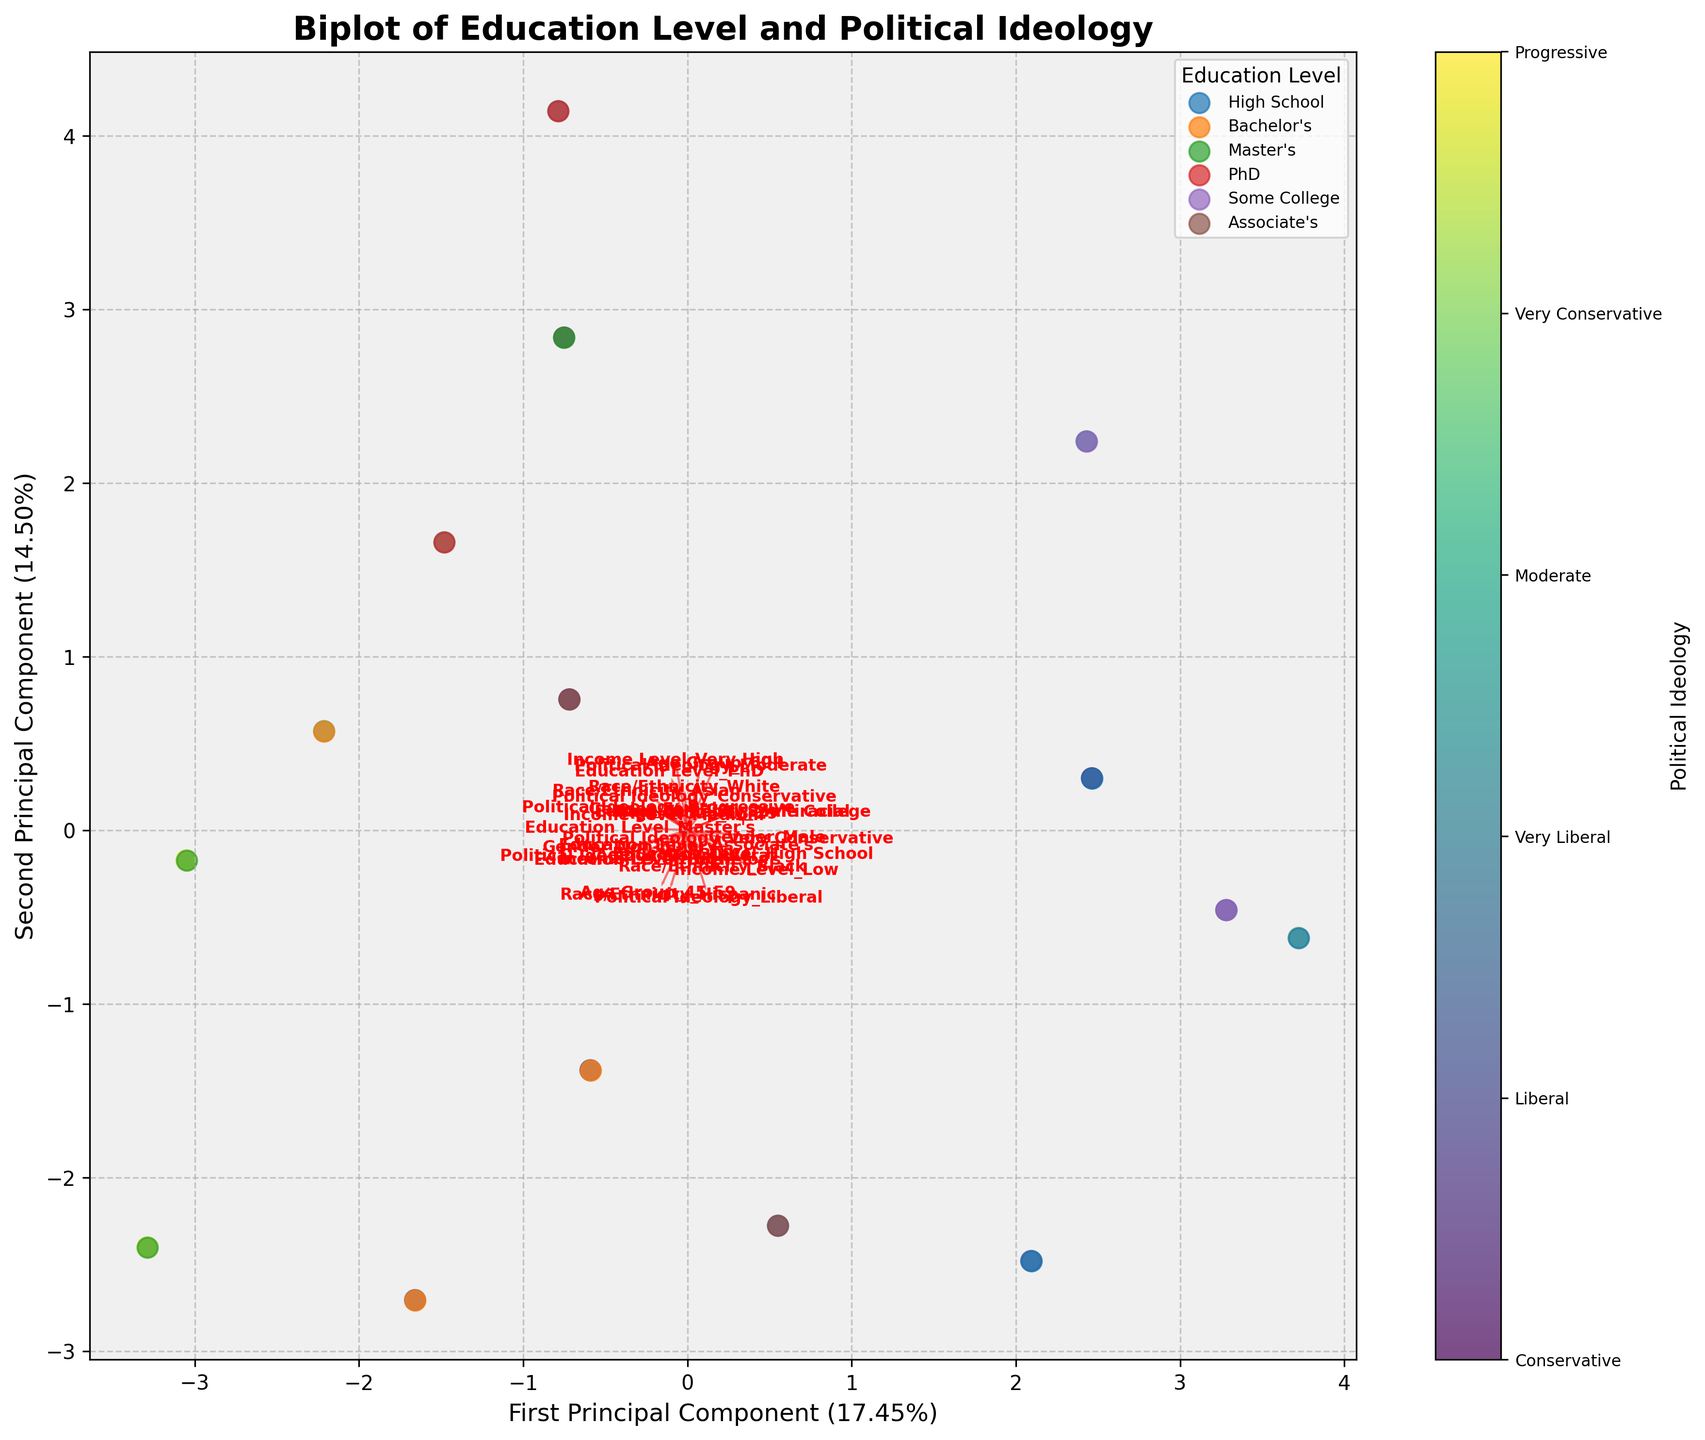What is the title of the biplot? The title of the biplot is the text displayed at the top of the figure, which summarizes the purpose of the plot. The title can usually be found in larger or bolder font compared to other text in the figure.
Answer: Biplot of Education Level and Political Ideology What are the components represented on the x-axis and y-axis? The x-axis and y-axis typically represent the first and second principal components derived from PCA, each showing a percentage that represents the explained variance by that component. The axis titles provide this information.
Answer: First Principal Component, Second Principal Component How many distinct education levels are defined in the legend? The legend shows different colored markers for each unique education level present in the data, helping to differentiate them visually on the plot. By counting the distinct labels, we can identify the number of education levels.
Answer: 7 Which political ideology is represented by the most prominent color in the scatter plot? The color bar next to the scatter plot is labeled with political ideologies, and each color corresponds to a different ideology. By observing the scatter plot, the viewer can note which color appears most frequently and refer to the color bar for its associated ideology.
Answer: Liberal 